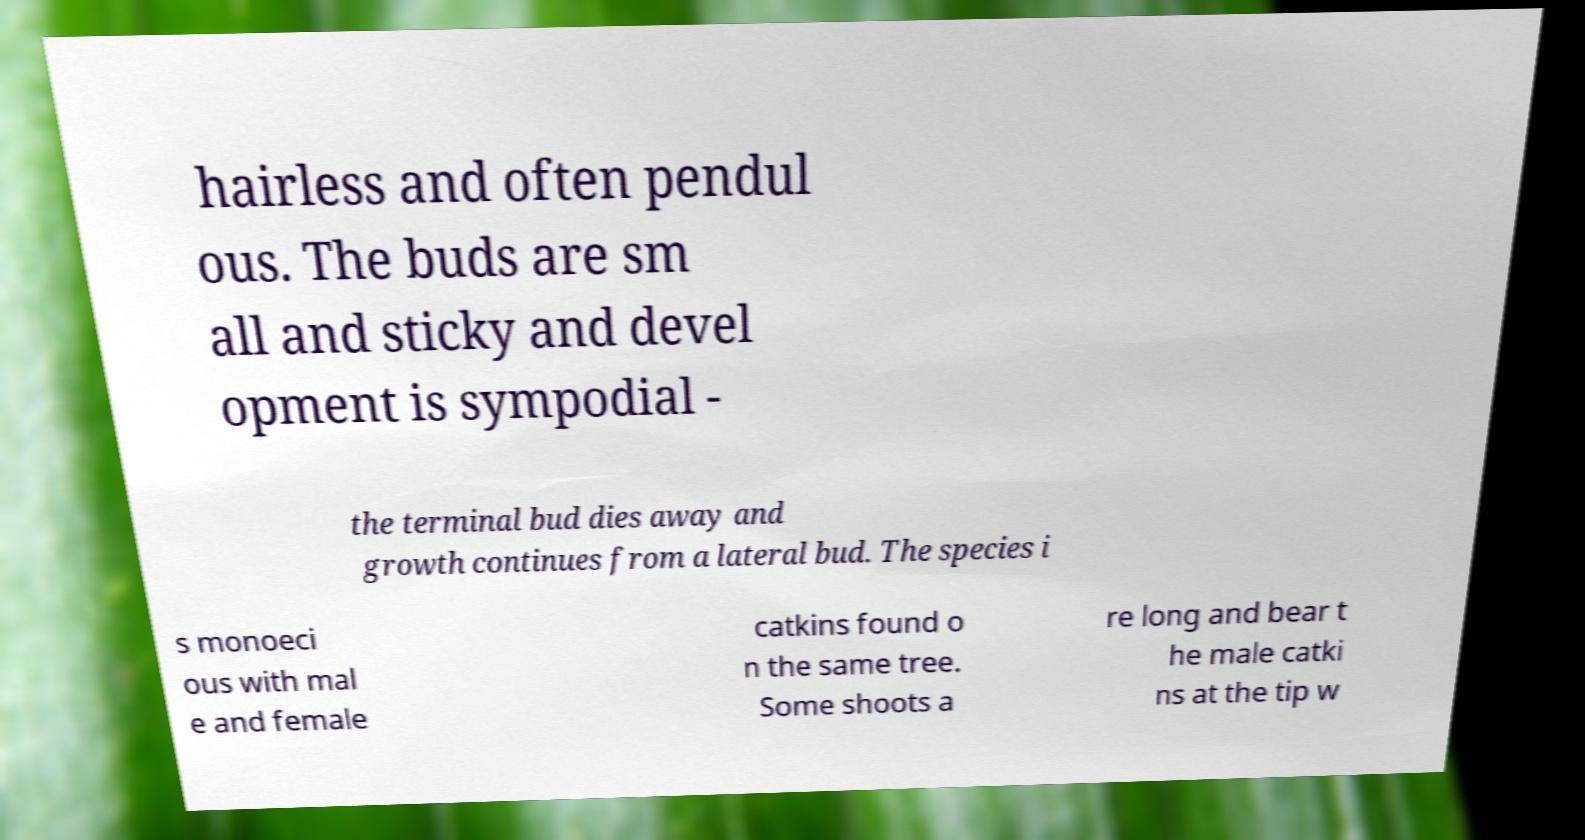I need the written content from this picture converted into text. Can you do that? hairless and often pendul ous. The buds are sm all and sticky and devel opment is sympodial - the terminal bud dies away and growth continues from a lateral bud. The species i s monoeci ous with mal e and female catkins found o n the same tree. Some shoots a re long and bear t he male catki ns at the tip w 